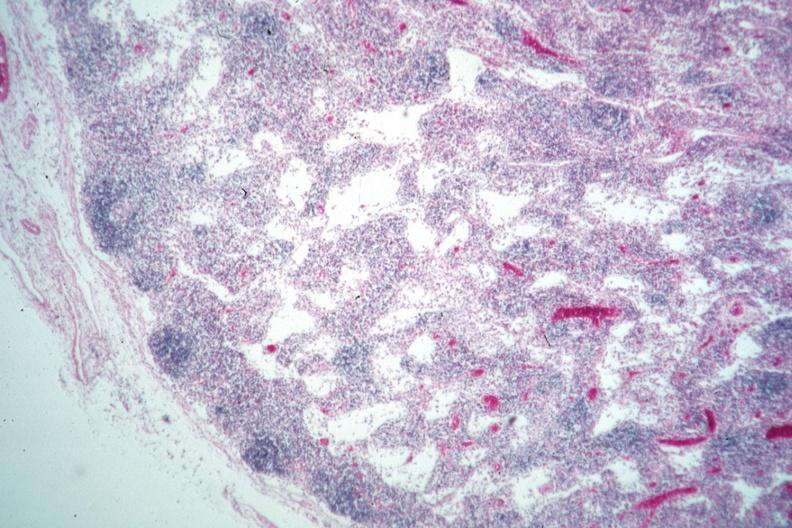what is present?
Answer the question using a single word or phrase. Lymph node 